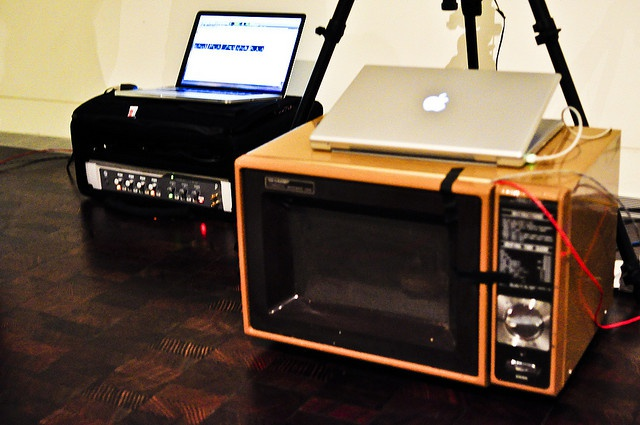Describe the objects in this image and their specific colors. I can see microwave in khaki, black, orange, maroon, and red tones, oven in khaki, black, orange, maroon, and red tones, laptop in khaki, tan, and ivory tones, and laptop in khaki, white, black, and lightblue tones in this image. 